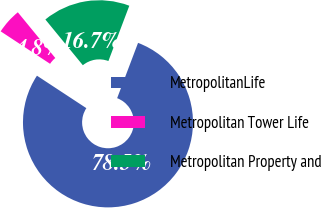Convert chart. <chart><loc_0><loc_0><loc_500><loc_500><pie_chart><fcel>MetropolitanLife<fcel>Metropolitan Tower Life<fcel>Metropolitan Property and<nl><fcel>78.5%<fcel>4.82%<fcel>16.68%<nl></chart> 